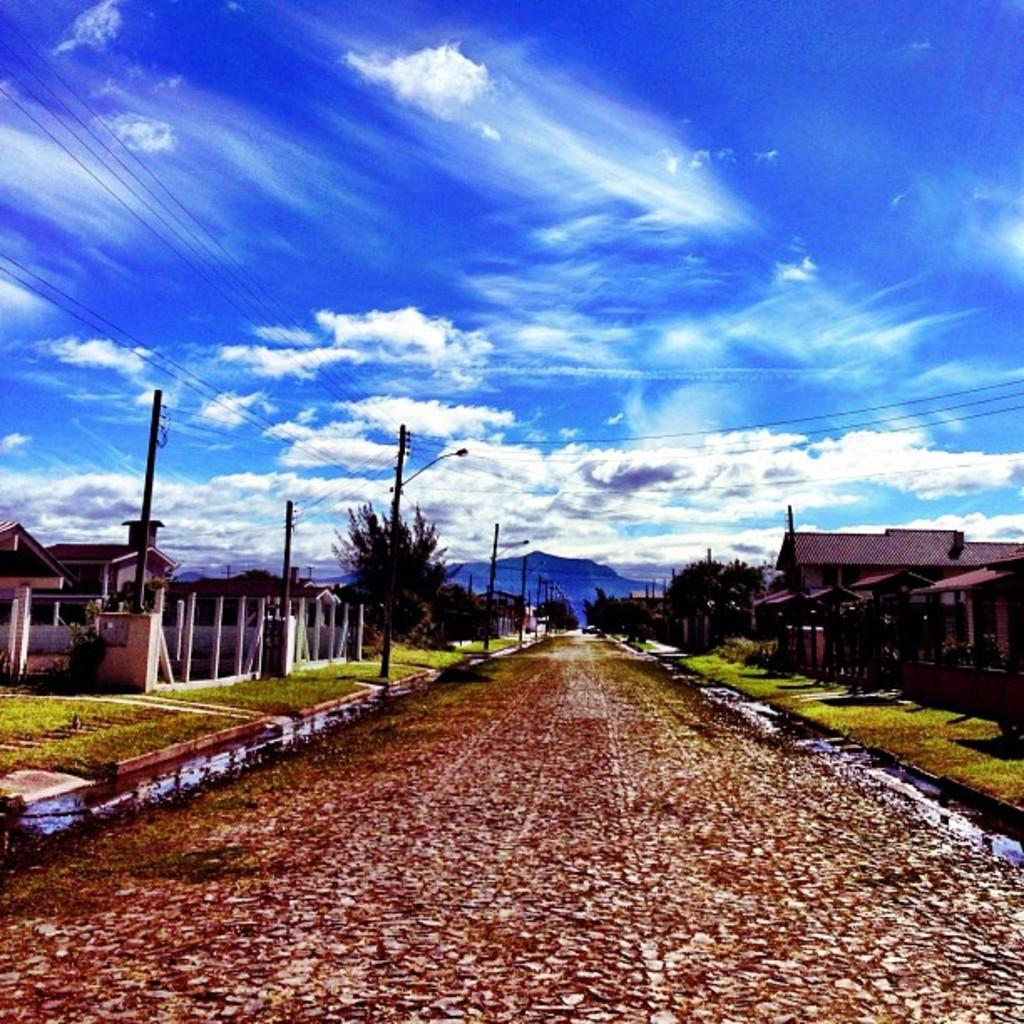What is the condition of the sky in the image? The sky is clear and blue with clouds. What can be seen on either side of the road in the image? There are trees, grass, and houses on either side of the road. Are there any visible polls in the image? Yes, there are current polls visible on the left side of the picture. Can you see a nest in one of the trees in the image? There is no nest visible in the image; only trees, grass, houses, and polls are present. What is the profit margin of the houses in the image? The image does not provide information about the profit margin of the houses; it only shows their presence on either side of the road. 